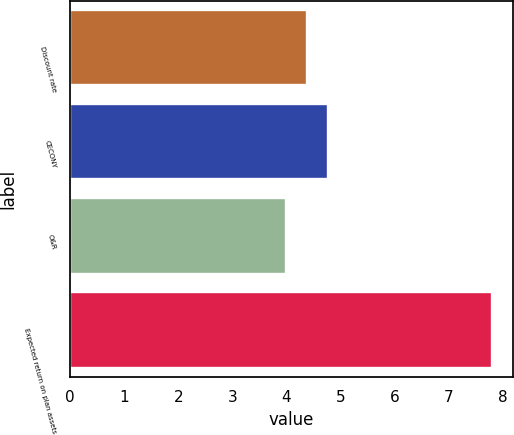<chart> <loc_0><loc_0><loc_500><loc_500><bar_chart><fcel>Discount rate<fcel>CECONY<fcel>O&R<fcel>Expected return on plan assets<nl><fcel>4.38<fcel>4.76<fcel>4<fcel>7.8<nl></chart> 